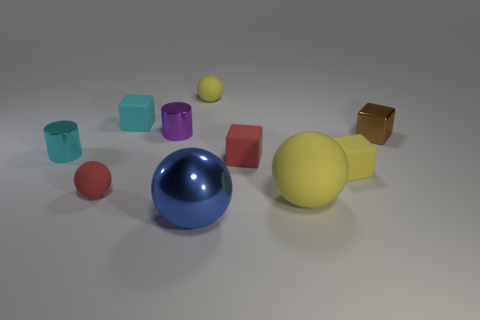Subtract all yellow balls. Subtract all purple cylinders. How many balls are left? 2 Subtract all cubes. How many objects are left? 6 Add 4 red rubber cubes. How many red rubber cubes are left? 5 Add 1 small red cubes. How many small red cubes exist? 2 Subtract 0 green balls. How many objects are left? 10 Subtract all cyan cubes. Subtract all big blue metal things. How many objects are left? 8 